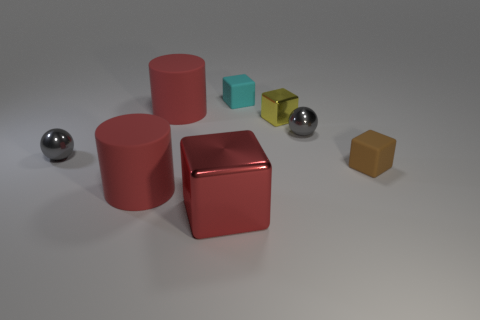Are there any other things that have the same color as the big shiny cube?
Give a very brief answer. Yes. Are there any cylinders to the left of the large red rubber thing in front of the small thing that is to the left of the large block?
Your answer should be very brief. No. Is the shape of the tiny shiny object that is left of the red metallic cube the same as  the brown rubber thing?
Ensure brevity in your answer.  No. Is the number of brown things that are left of the small metallic cube less than the number of brown things to the left of the tiny cyan block?
Your answer should be very brief. No. What is the tiny cyan block made of?
Keep it short and to the point. Rubber. Does the big metallic object have the same color as the shiny cube that is to the right of the red metallic block?
Offer a very short reply. No. What number of things are in front of the large metallic thing?
Offer a terse response. 0. Is the number of brown rubber cubes that are on the right side of the big red metallic object less than the number of red rubber cylinders?
Your response must be concise. Yes. The tiny shiny block is what color?
Your answer should be compact. Yellow. There is a tiny metallic ball on the right side of the big red cube; does it have the same color as the big metallic thing?
Keep it short and to the point. No. 